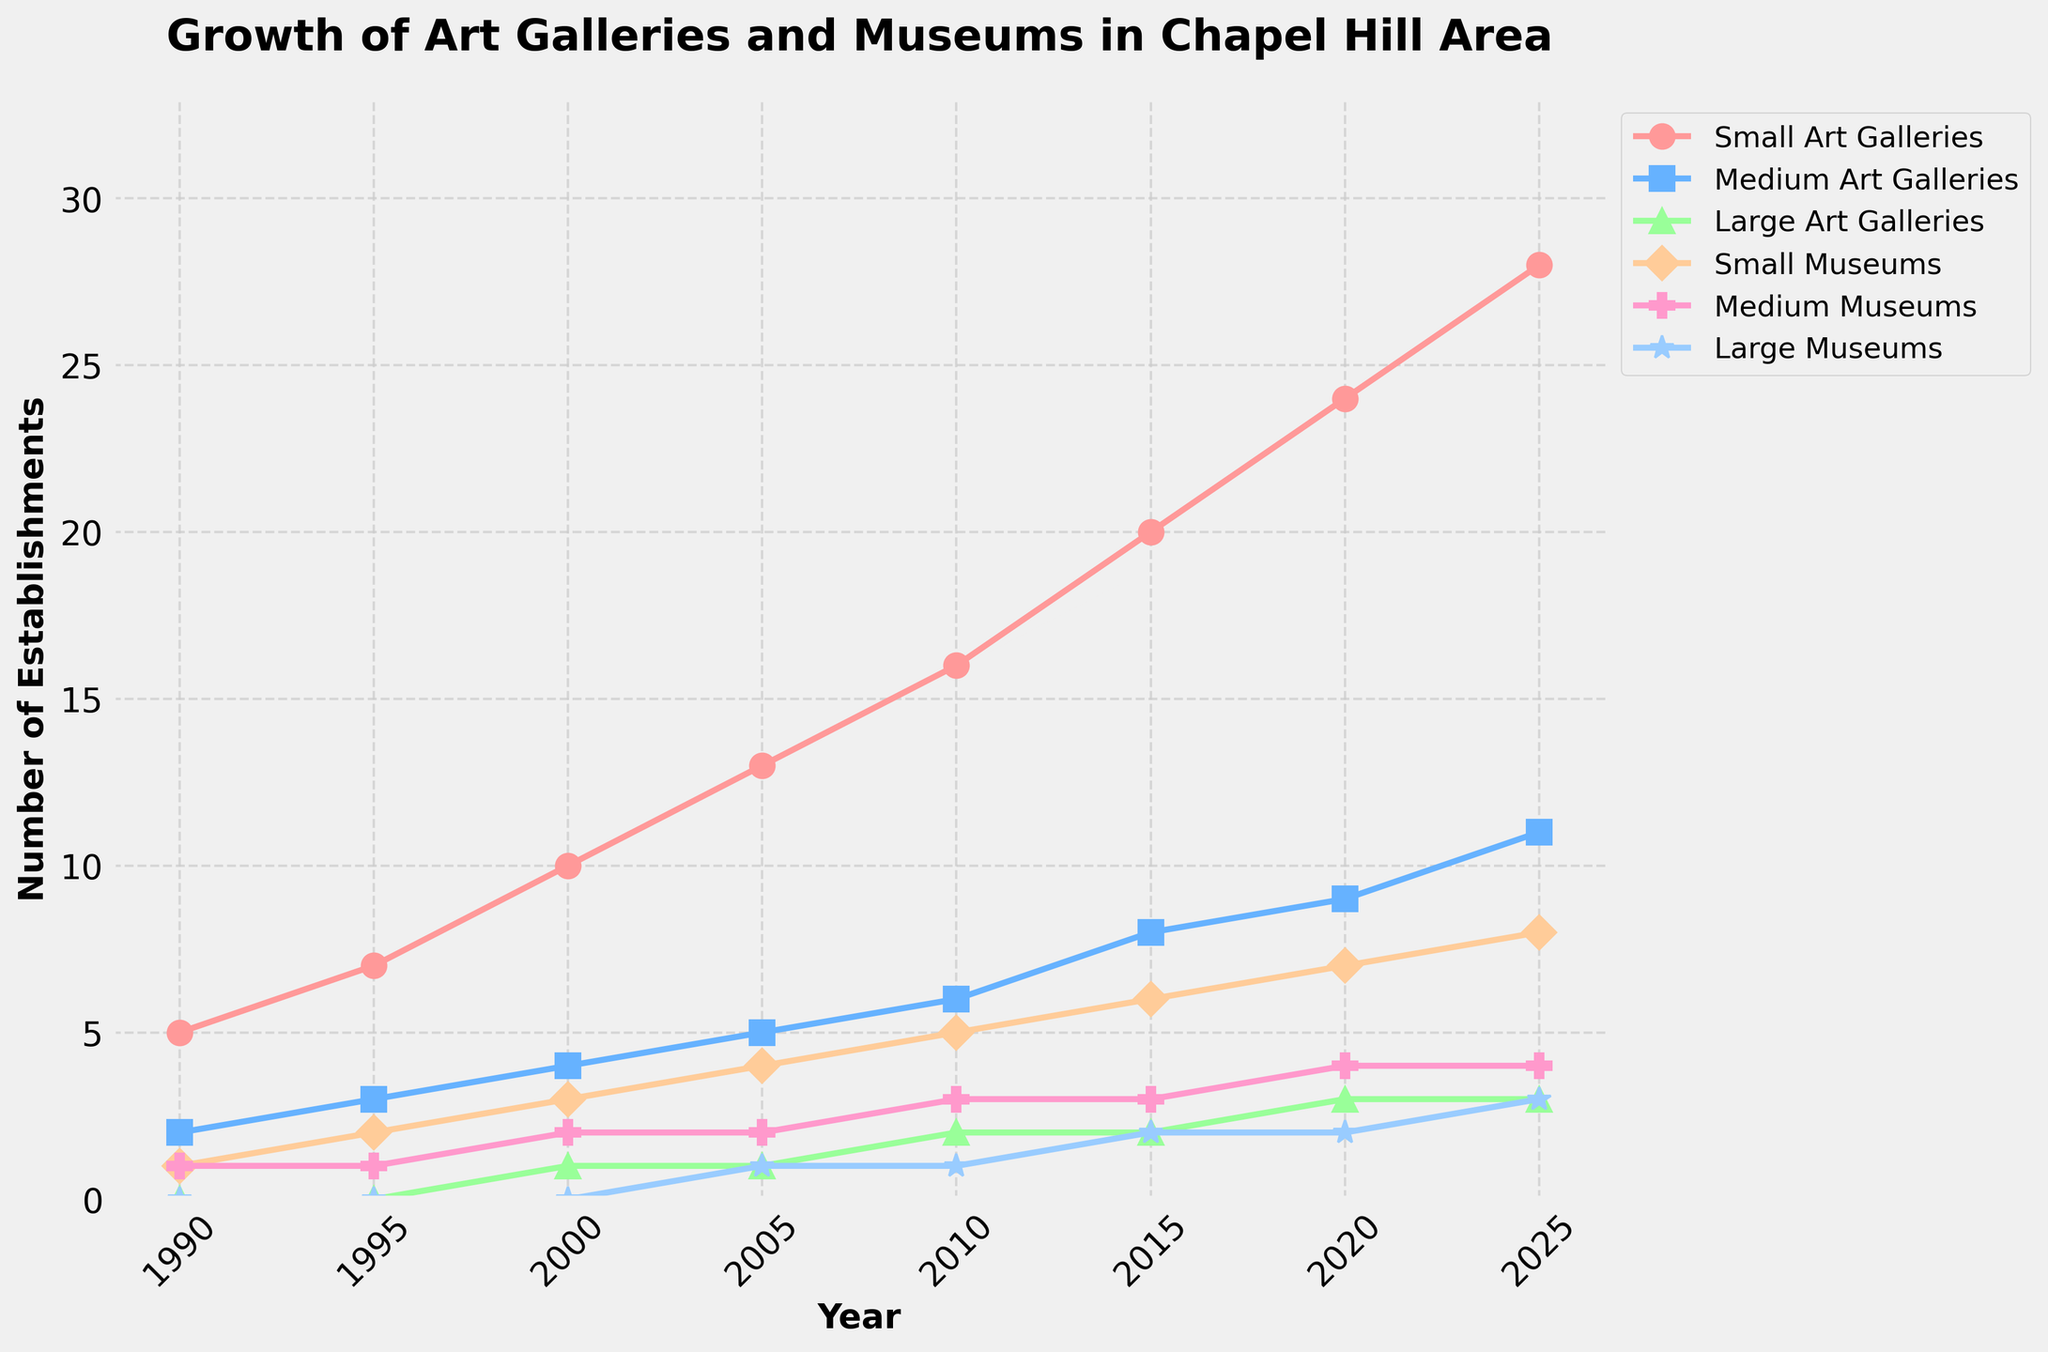What year did the number of medium museums first equal the number of medium art galleries? By looking at the plot, we observe the intersection of the lines for medium museums and medium art galleries. The intersection where both have roughly equal values occurs in the year 2025.
Answer: 2025 In what year did small art galleries surpass 20 establishments? The plot shows the line for small art galleries crossing the 20 establishments mark between the years 2010 and 2015. The exact year is 2015.
Answer: 2015 How many more large museums are there in 2025 compared to 1990? According to the plot, large museums are shown as having 0 in 1990 and 3 in 2025. The difference is 3 - 0 = 3.
Answer: 3 Which category experienced the most significant increase from 1990 to 2025? To determine the most significant increase, observe the slopes of the lines from 1990 to 2025. Small art galleries have the steepest slope, increasing from 5 to 28 (a difference of 23).
Answer: Small Art Galleries In which five-year interval do medium art galleries see the largest increase? Examine the plot to determine the steepest portion of the line representing medium art galleries. The notable sharpest rise is between 2020 and 2025, increasing from 9 to 11 (a difference of 2).
Answer: 2020-2025 What's the total number of all categories combined in the year 2000? Sum the numbers in all categories for the year 2000: Small Art Galleries (10) + Medium Art Galleries (4) + Large Art Galleries (1) + Small Museums (3) + Medium Museums (2) + Large Museums (0). Total = 10 + 4 + 1 + 3 + 2 + 0 = 20.
Answer: 20 Which category appears to remain the smallest throughout all the years? By analyzing the heights (values) of the lines, Large Museums consistently have the lowest values compared to other categories.
Answer: Large Museums What is the average number of medium art galleries from 1990 to 2025? Calculate the average by adding the yearly numbers from 1990 to 2025 for medium art galleries and dividing by the number of years: (2 + 3 + 4 + 5 + 6 + 8 + 9 + 11) / 8 = 48 / 8 = 6.
Answer: 6 Do large art galleries ever exceed large museums in any given year? Compare the line representing large art galleries with the line representing large museums. Large art galleries have higher values than large museums in 2000, 2010, and 2015.
Answer: Yes 